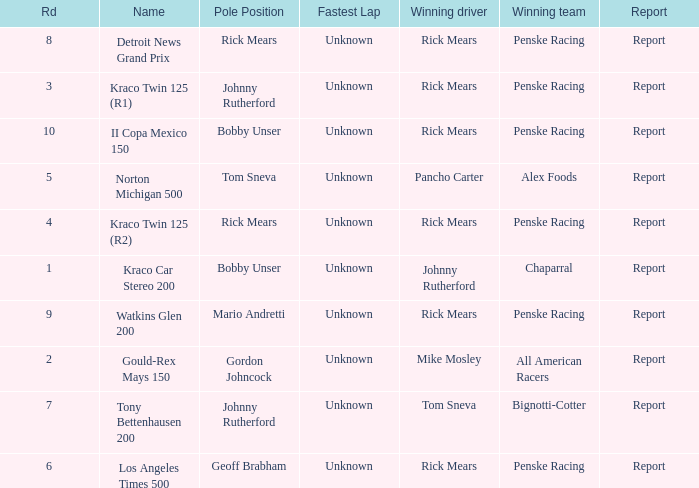The winning team of the race, los angeles times 500 is who? Penske Racing. 